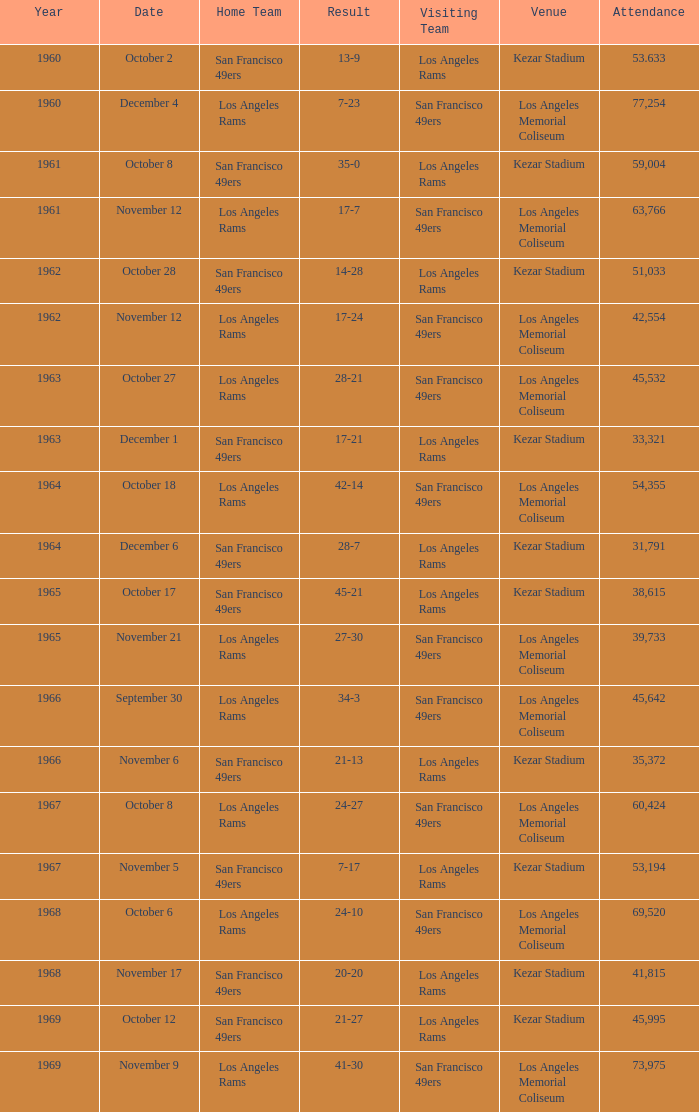What was the earliest year with an attendance of 77,254? 1960.0. 